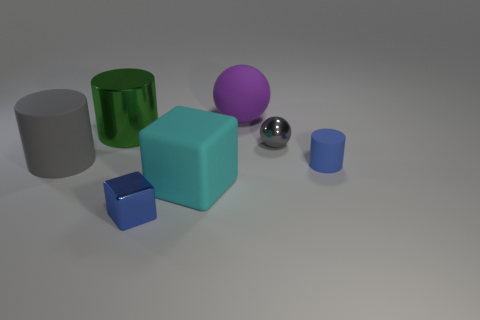Which objects are closer to the camera? The blue cube and the smaller blue cylinder are closest to the camera, positioned at the lower right corner of the image. 